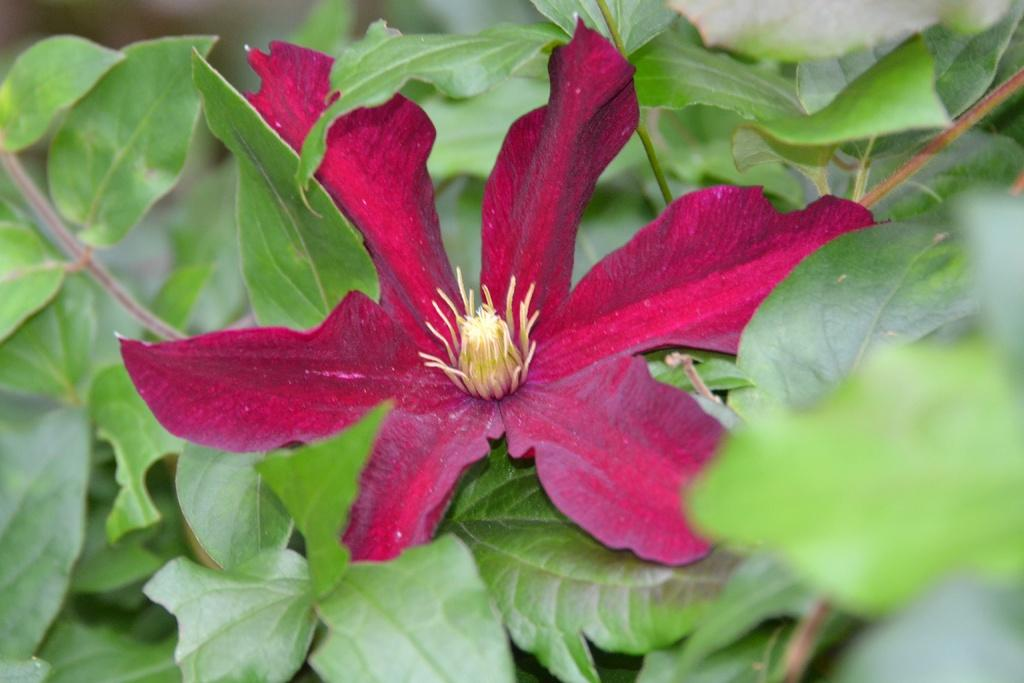What is the main subject of the image? There is a flower in the image. What can be seen on the stem of the flower? The flower has leaves on its stem. How would you describe the background of the image? The background of the image is blurred. What type of bun is being used to hold the peace sign in the image? There is no bun or peace sign present in the image; it features a flower with leaves on its stem and a blurred background. 